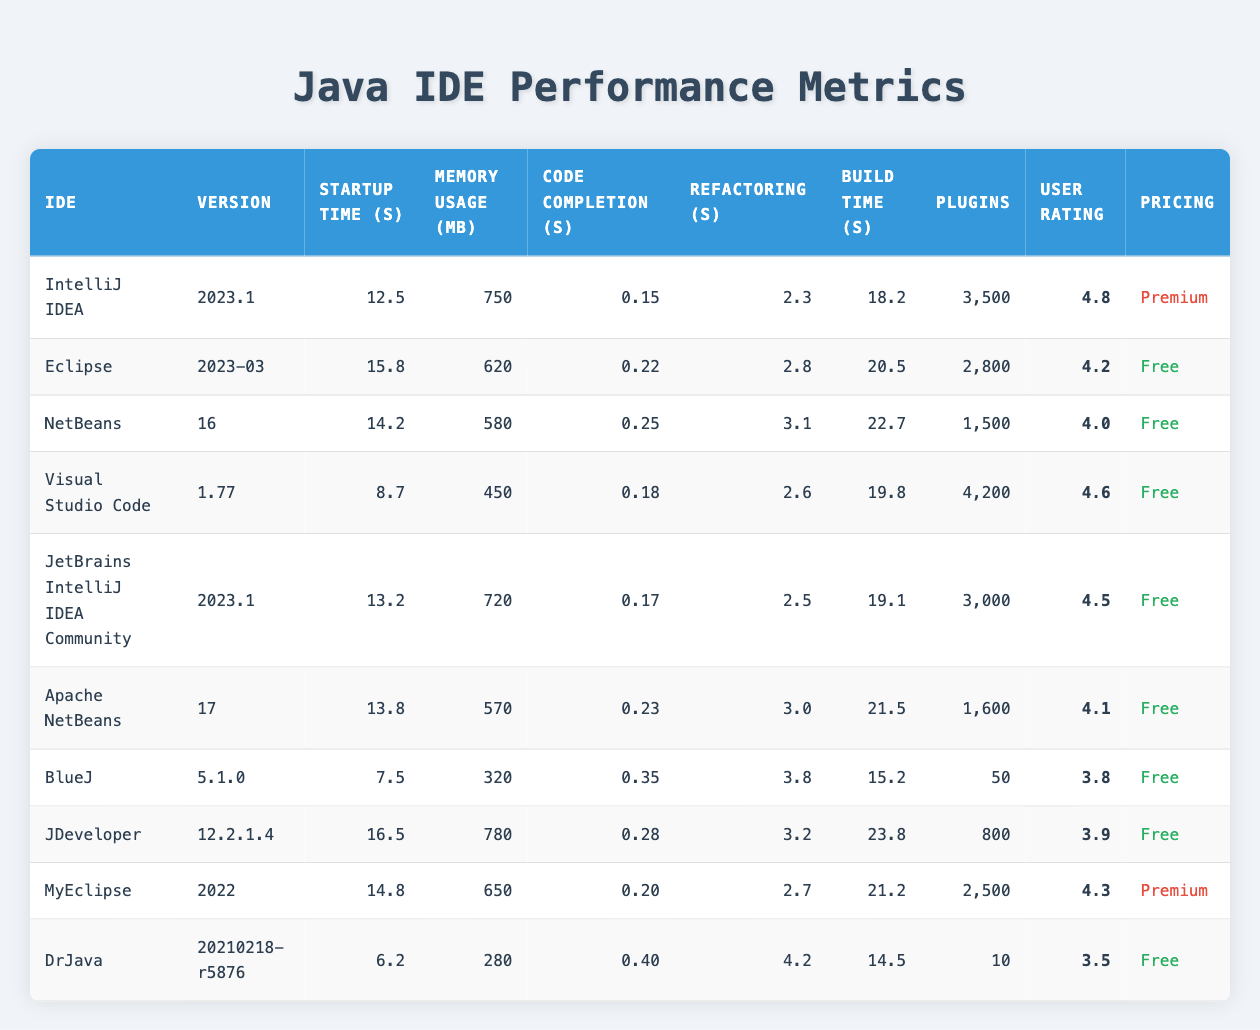What is the IDE with the highest user rating? By reviewing the "User Rating" column, we find that "IntelliJ IDEA" has the highest rating of 4.8.
Answer: IntelliJ IDEA What is the average startup time of all IDEs listed? To calculate the average startup time, we sum the startup times (12.5 + 15.8 + 14.2 + 8.7 + 13.2 + 13.8 + 7.5 + 16.5 + 14.8 + 6.2) =  130.0, then divide by the number of IDEs (10). Thus, the average startup time is 130.0 / 10 = 13.0 seconds.
Answer: 13.0 seconds How many IDEs have a code completion speed of less than 0.20 seconds? We need to check the "Code Completion" column for values less than 0.20. The valid IDEs are "Eclipse" (0.22), "NetBeans" (0.25), "Visual Studio Code" (0.18), "JetBrains IntelliJ IDEA Community" (0.17), "Apache NetBeans" (0.23), "BlueJ" (0.35), "JDeveloper" (0.28), "MyEclipse" (0.20), and "DrJava" (0.40). Only "Visual Studio Code" and "JetBrains IntelliJ IDEA Community" meet the criteria. Thus, there are 2 IDEs.
Answer: 2 Is the pricing tier for "MyEclipse" premium? Referring to the "Pricing" column for "MyEclipse", we can see that it is marked as "Premium".
Answer: Yes What is the IDE with the lowest memory usage? We look at the "Memory Usage" column and find that "DrJava" has the lowest memory usage of 280 MB compared to others.
Answer: DrJava Which IDE has the shortest build time? Checking the "Build Time" column, "DrJava" has the shortest build time of 14.5 seconds, making it the quickest.
Answer: DrJava How many plugins does "Visual Studio Code" have compared to "BlueJ"? "Visual Studio Code" has 4200 plugins, while "BlueJ" has 50. The difference in the number of plugins is 4200 - 50 = 4150.
Answer: 4150 Which IDE has the longest refactoring speed, and what is the value? Reviewing the "Refactoring" column, "DrJava" has the longest refactoring speed of 4.2 seconds, indicating it takes the longest time to refactor.
Answer: DrJava, 4.2 seconds How does the user rating for "Eclipse" compare with "NetBeans"? "Eclipse" has a user rating of 4.2 and "NetBeans" has a rating of 4.0. Comparing these, "Eclipse" has a higher rating than "NetBeans".
Answer: Eclipse is higher 